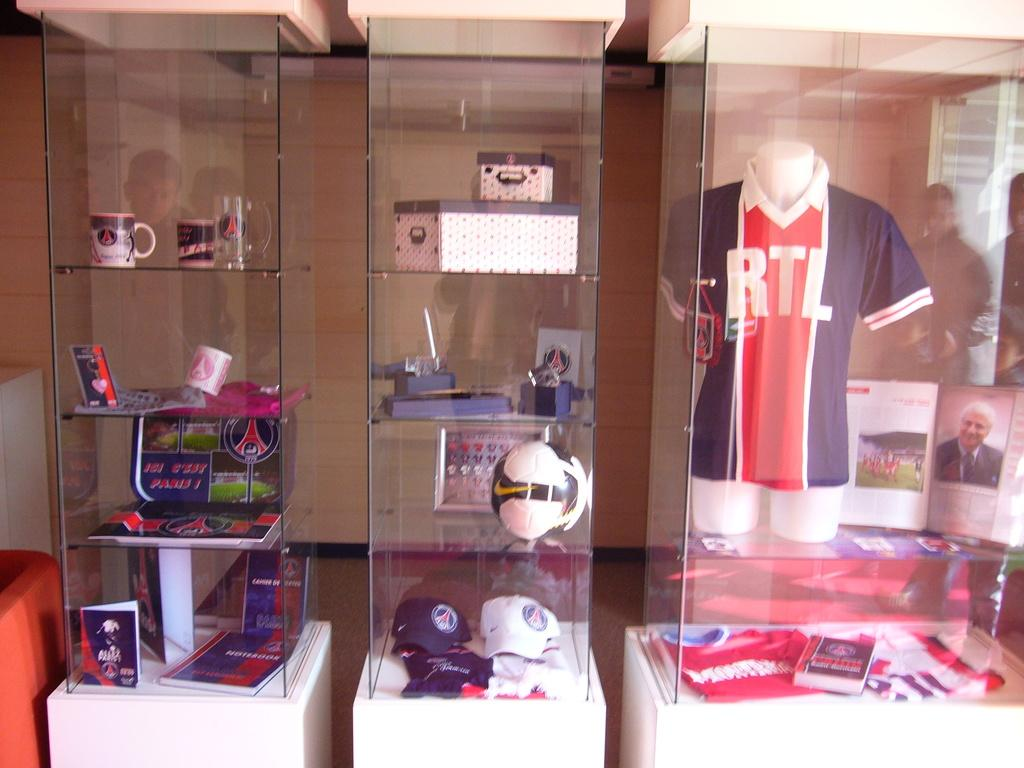What type of clothing item is on the mannequin in the image? There is a shirt on a mannequin in the image. What other items can be seen in the image besides the shirt? There is a group of caps, cups, boxes, a ball, and frames in the image. How are the items arranged in the image? The objects are placed on racks in the image. Can you describe the people in the background of the image? There is a group of people in the background of the image. What page of the book is the mannequin reading in the image? There is no book or reading activity present in the image. How does the ball swim in the image? The ball does not swim in the image; it is stationary on the rack. 